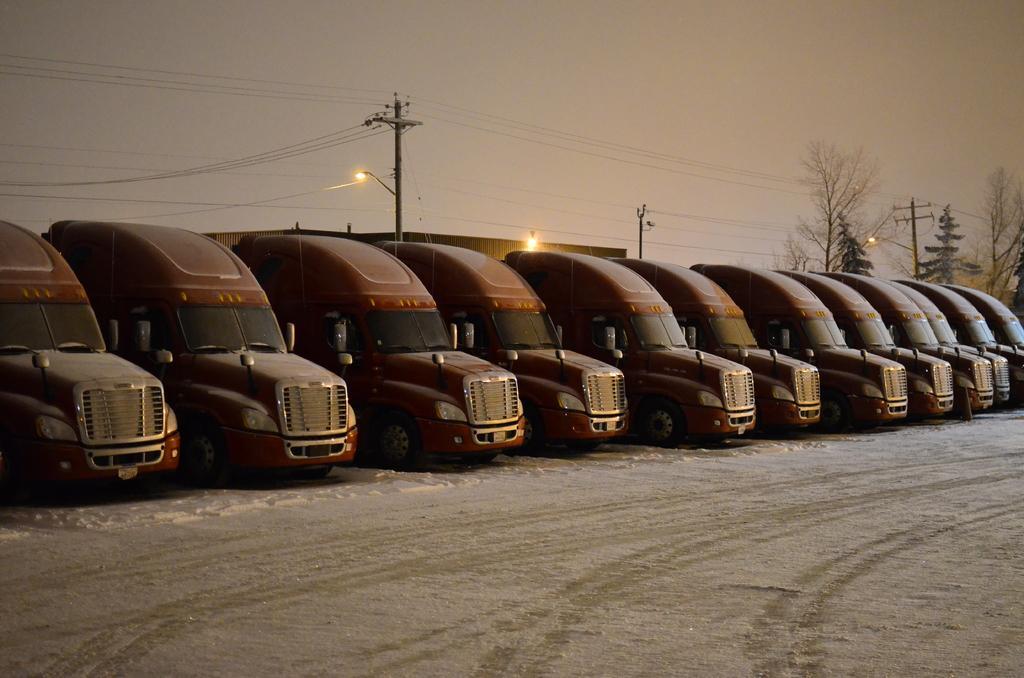Could you give a brief overview of what you see in this image? In this image we can see many trucks are parked on the side of the road. Here we can see the road covered with snow. In the background, we can see current poles, wires, light poles, trees, house and the plain sky. 